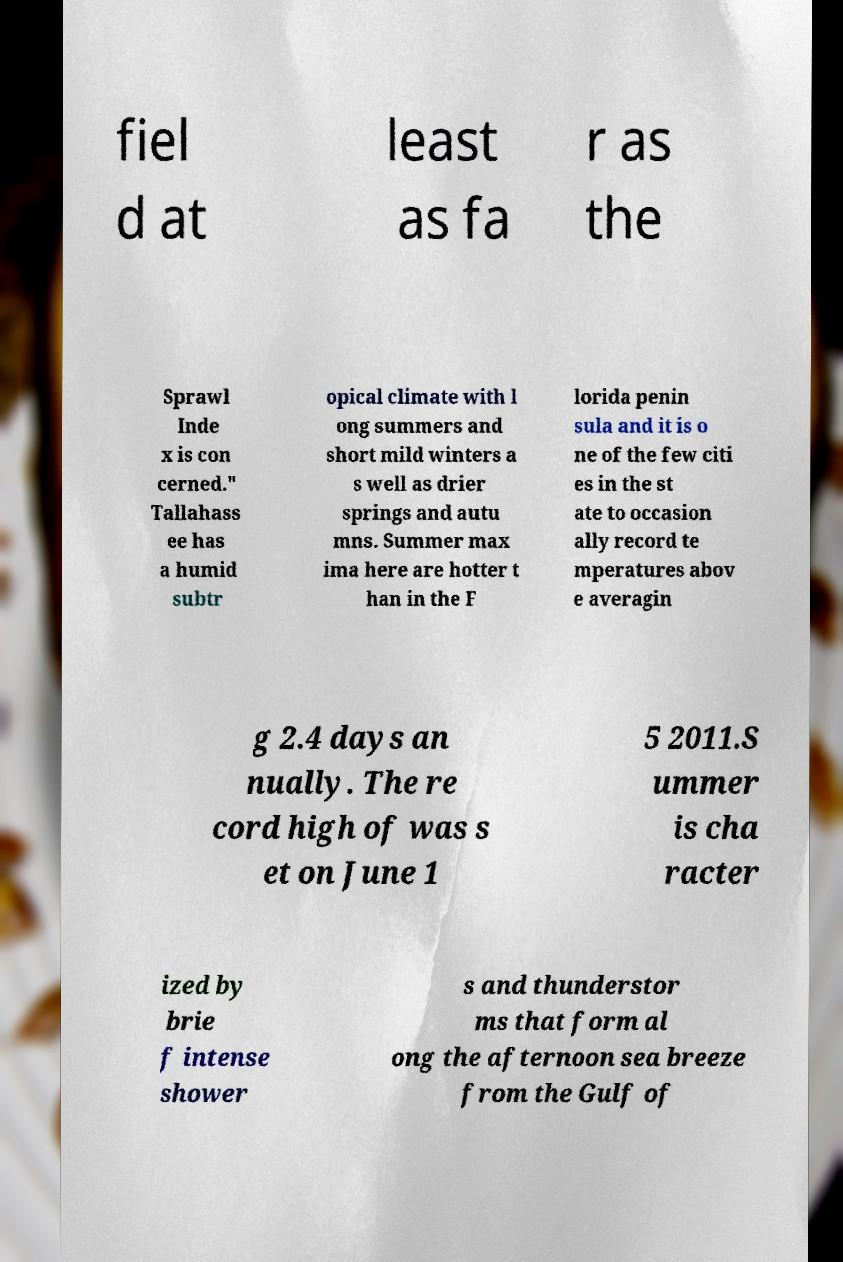Please identify and transcribe the text found in this image. fiel d at least as fa r as the Sprawl Inde x is con cerned." Tallahass ee has a humid subtr opical climate with l ong summers and short mild winters a s well as drier springs and autu mns. Summer max ima here are hotter t han in the F lorida penin sula and it is o ne of the few citi es in the st ate to occasion ally record te mperatures abov e averagin g 2.4 days an nually. The re cord high of was s et on June 1 5 2011.S ummer is cha racter ized by brie f intense shower s and thunderstor ms that form al ong the afternoon sea breeze from the Gulf of 